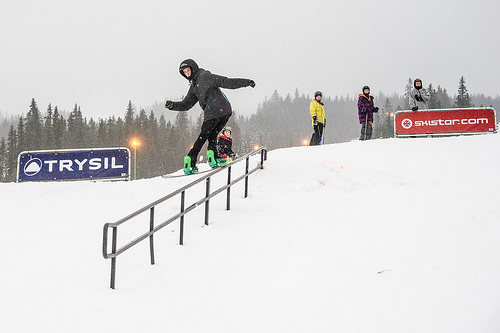Which color do you think the jacket the man is wearing is? The jacket that the man is wearing appears to be gray, blending subtly with the overcast sky. 